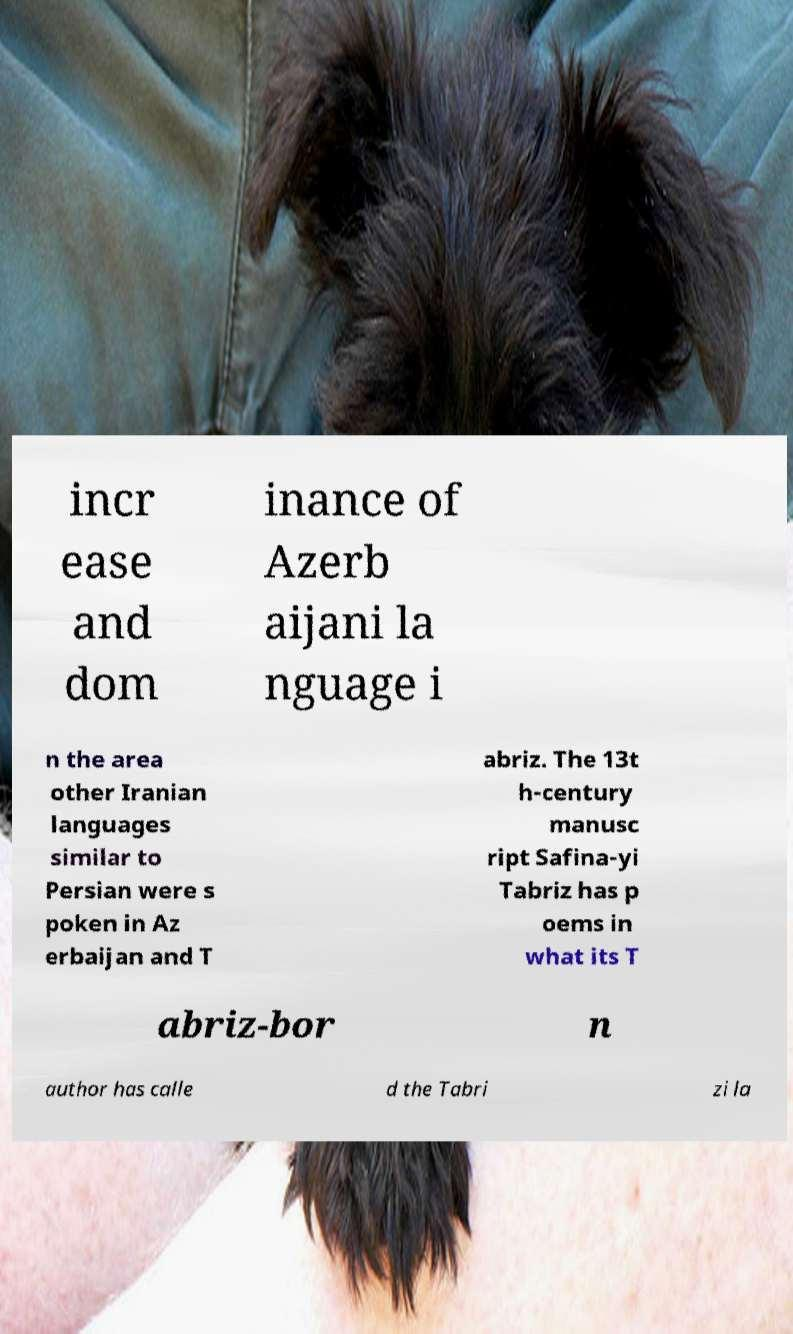What messages or text are displayed in this image? I need them in a readable, typed format. incr ease and dom inance of Azerb aijani la nguage i n the area other Iranian languages similar to Persian were s poken in Az erbaijan and T abriz. The 13t h-century manusc ript Safina-yi Tabriz has p oems in what its T abriz-bor n author has calle d the Tabri zi la 